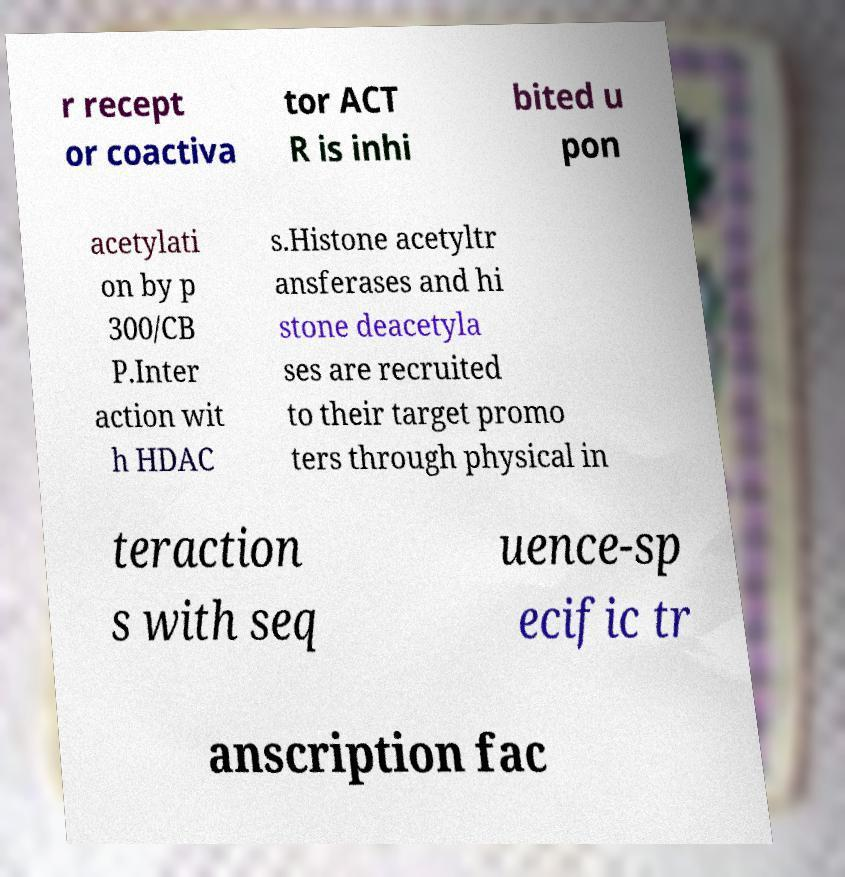There's text embedded in this image that I need extracted. Can you transcribe it verbatim? r recept or coactiva tor ACT R is inhi bited u pon acetylati on by p 300/CB P.Inter action wit h HDAC s.Histone acetyltr ansferases and hi stone deacetyla ses are recruited to their target promo ters through physical in teraction s with seq uence-sp ecific tr anscription fac 